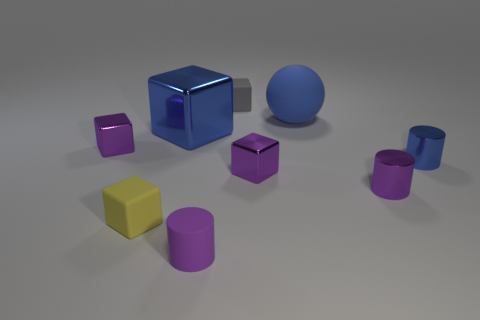Does the purple object in front of the purple metallic cylinder have the same shape as the yellow thing?
Make the answer very short. No. Are there any blue balls of the same size as the gray cube?
Your answer should be compact. No. There is a small yellow rubber thing; is its shape the same as the purple object behind the blue metallic cylinder?
Your response must be concise. Yes. There is a small thing that is the same color as the big metallic cube; what shape is it?
Your answer should be compact. Cylinder. Is the number of yellow matte objects that are in front of the purple matte cylinder less than the number of balls?
Give a very brief answer. Yes. Does the tiny blue metal object have the same shape as the tiny purple matte thing?
Your answer should be very brief. Yes. What is the size of the blue thing that is made of the same material as the tiny blue cylinder?
Make the answer very short. Large. Is the number of small blue shiny cylinders less than the number of tiny cylinders?
Offer a very short reply. Yes. What number of big things are blue spheres or blocks?
Your answer should be compact. 2. How many matte things are behind the large metal cube and in front of the tiny yellow object?
Offer a very short reply. 0. 